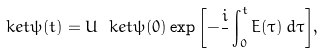Convert formula to latex. <formula><loc_0><loc_0><loc_500><loc_500>\ k e t { \psi ( t ) } = U \ k e t { \psi ( 0 ) } \exp { \left [ - \frac { i } { } \int _ { 0 } ^ { t } E ( \tau ) \, d \tau \right ] } ,</formula> 